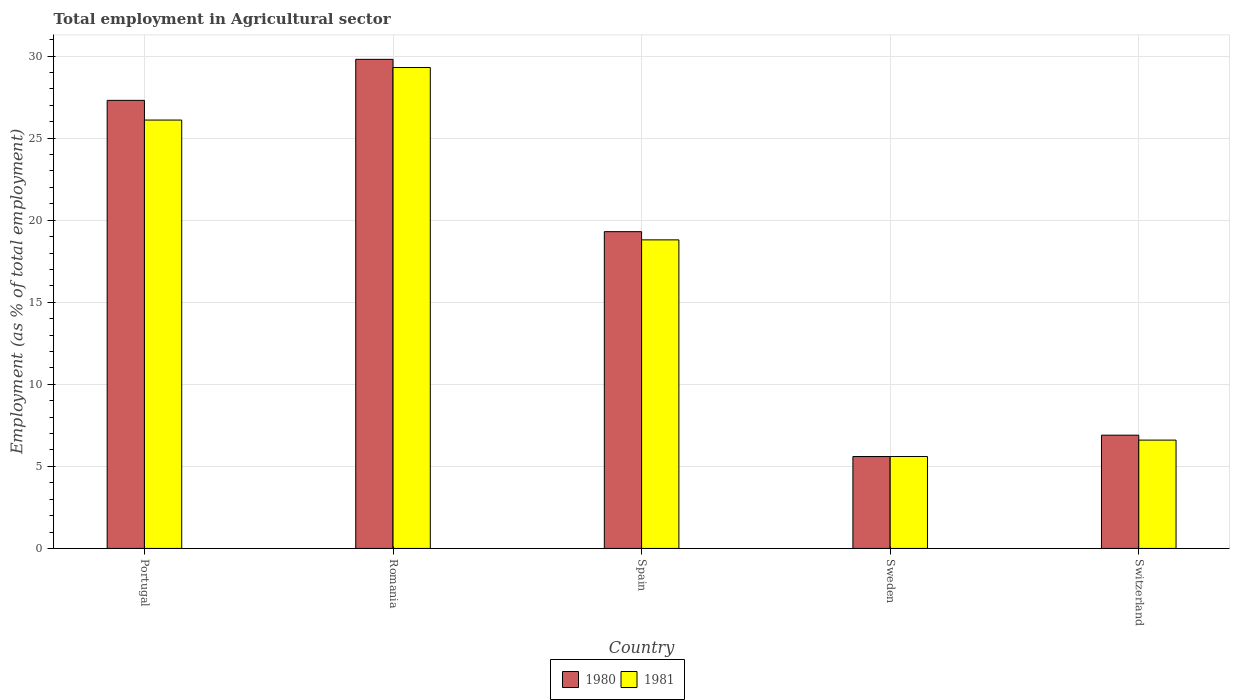How many bars are there on the 2nd tick from the right?
Ensure brevity in your answer.  2. What is the label of the 5th group of bars from the left?
Keep it short and to the point. Switzerland. What is the employment in agricultural sector in 1980 in Spain?
Your answer should be compact. 19.3. Across all countries, what is the maximum employment in agricultural sector in 1981?
Your answer should be very brief. 29.3. Across all countries, what is the minimum employment in agricultural sector in 1980?
Give a very brief answer. 5.6. In which country was the employment in agricultural sector in 1980 maximum?
Provide a succinct answer. Romania. What is the total employment in agricultural sector in 1980 in the graph?
Your answer should be compact. 88.9. What is the difference between the employment in agricultural sector in 1980 in Sweden and that in Switzerland?
Your answer should be compact. -1.3. What is the difference between the employment in agricultural sector in 1980 in Sweden and the employment in agricultural sector in 1981 in Portugal?
Your answer should be compact. -20.5. What is the average employment in agricultural sector in 1980 per country?
Offer a very short reply. 17.78. What is the ratio of the employment in agricultural sector in 1981 in Portugal to that in Switzerland?
Give a very brief answer. 3.95. Is the employment in agricultural sector in 1981 in Portugal less than that in Spain?
Your answer should be very brief. No. Is the difference between the employment in agricultural sector in 1980 in Spain and Switzerland greater than the difference between the employment in agricultural sector in 1981 in Spain and Switzerland?
Give a very brief answer. Yes. What is the difference between the highest and the second highest employment in agricultural sector in 1980?
Provide a short and direct response. -8. What is the difference between the highest and the lowest employment in agricultural sector in 1980?
Give a very brief answer. 24.2. In how many countries, is the employment in agricultural sector in 1981 greater than the average employment in agricultural sector in 1981 taken over all countries?
Keep it short and to the point. 3. Is the sum of the employment in agricultural sector in 1981 in Spain and Sweden greater than the maximum employment in agricultural sector in 1980 across all countries?
Offer a very short reply. No. How many bars are there?
Keep it short and to the point. 10. What is the difference between two consecutive major ticks on the Y-axis?
Your response must be concise. 5. Are the values on the major ticks of Y-axis written in scientific E-notation?
Your answer should be compact. No. Does the graph contain any zero values?
Keep it short and to the point. No. Does the graph contain grids?
Ensure brevity in your answer.  Yes. How many legend labels are there?
Offer a very short reply. 2. How are the legend labels stacked?
Offer a very short reply. Horizontal. What is the title of the graph?
Give a very brief answer. Total employment in Agricultural sector. Does "1979" appear as one of the legend labels in the graph?
Provide a short and direct response. No. What is the label or title of the X-axis?
Your response must be concise. Country. What is the label or title of the Y-axis?
Your answer should be very brief. Employment (as % of total employment). What is the Employment (as % of total employment) of 1980 in Portugal?
Make the answer very short. 27.3. What is the Employment (as % of total employment) in 1981 in Portugal?
Give a very brief answer. 26.1. What is the Employment (as % of total employment) of 1980 in Romania?
Make the answer very short. 29.8. What is the Employment (as % of total employment) of 1981 in Romania?
Your answer should be compact. 29.3. What is the Employment (as % of total employment) in 1980 in Spain?
Make the answer very short. 19.3. What is the Employment (as % of total employment) of 1981 in Spain?
Your answer should be very brief. 18.8. What is the Employment (as % of total employment) in 1980 in Sweden?
Your response must be concise. 5.6. What is the Employment (as % of total employment) in 1981 in Sweden?
Your answer should be very brief. 5.6. What is the Employment (as % of total employment) in 1980 in Switzerland?
Ensure brevity in your answer.  6.9. What is the Employment (as % of total employment) in 1981 in Switzerland?
Give a very brief answer. 6.6. Across all countries, what is the maximum Employment (as % of total employment) of 1980?
Offer a terse response. 29.8. Across all countries, what is the maximum Employment (as % of total employment) in 1981?
Give a very brief answer. 29.3. Across all countries, what is the minimum Employment (as % of total employment) in 1980?
Your response must be concise. 5.6. Across all countries, what is the minimum Employment (as % of total employment) of 1981?
Keep it short and to the point. 5.6. What is the total Employment (as % of total employment) in 1980 in the graph?
Make the answer very short. 88.9. What is the total Employment (as % of total employment) in 1981 in the graph?
Ensure brevity in your answer.  86.4. What is the difference between the Employment (as % of total employment) in 1980 in Portugal and that in Romania?
Provide a short and direct response. -2.5. What is the difference between the Employment (as % of total employment) in 1980 in Portugal and that in Spain?
Provide a short and direct response. 8. What is the difference between the Employment (as % of total employment) of 1981 in Portugal and that in Spain?
Offer a terse response. 7.3. What is the difference between the Employment (as % of total employment) of 1980 in Portugal and that in Sweden?
Offer a very short reply. 21.7. What is the difference between the Employment (as % of total employment) of 1981 in Portugal and that in Sweden?
Offer a very short reply. 20.5. What is the difference between the Employment (as % of total employment) in 1980 in Portugal and that in Switzerland?
Your answer should be very brief. 20.4. What is the difference between the Employment (as % of total employment) of 1980 in Romania and that in Sweden?
Offer a very short reply. 24.2. What is the difference between the Employment (as % of total employment) in 1981 in Romania and that in Sweden?
Offer a very short reply. 23.7. What is the difference between the Employment (as % of total employment) in 1980 in Romania and that in Switzerland?
Offer a very short reply. 22.9. What is the difference between the Employment (as % of total employment) in 1981 in Romania and that in Switzerland?
Your response must be concise. 22.7. What is the difference between the Employment (as % of total employment) of 1980 in Spain and that in Sweden?
Give a very brief answer. 13.7. What is the difference between the Employment (as % of total employment) of 1980 in Spain and that in Switzerland?
Keep it short and to the point. 12.4. What is the difference between the Employment (as % of total employment) in 1981 in Sweden and that in Switzerland?
Your answer should be very brief. -1. What is the difference between the Employment (as % of total employment) in 1980 in Portugal and the Employment (as % of total employment) in 1981 in Spain?
Ensure brevity in your answer.  8.5. What is the difference between the Employment (as % of total employment) in 1980 in Portugal and the Employment (as % of total employment) in 1981 in Sweden?
Your response must be concise. 21.7. What is the difference between the Employment (as % of total employment) in 1980 in Portugal and the Employment (as % of total employment) in 1981 in Switzerland?
Keep it short and to the point. 20.7. What is the difference between the Employment (as % of total employment) of 1980 in Romania and the Employment (as % of total employment) of 1981 in Spain?
Give a very brief answer. 11. What is the difference between the Employment (as % of total employment) in 1980 in Romania and the Employment (as % of total employment) in 1981 in Sweden?
Offer a terse response. 24.2. What is the difference between the Employment (as % of total employment) of 1980 in Romania and the Employment (as % of total employment) of 1981 in Switzerland?
Offer a terse response. 23.2. What is the difference between the Employment (as % of total employment) in 1980 in Spain and the Employment (as % of total employment) in 1981 in Sweden?
Keep it short and to the point. 13.7. What is the difference between the Employment (as % of total employment) in 1980 in Spain and the Employment (as % of total employment) in 1981 in Switzerland?
Offer a very short reply. 12.7. What is the difference between the Employment (as % of total employment) in 1980 in Sweden and the Employment (as % of total employment) in 1981 in Switzerland?
Your answer should be compact. -1. What is the average Employment (as % of total employment) in 1980 per country?
Offer a very short reply. 17.78. What is the average Employment (as % of total employment) of 1981 per country?
Keep it short and to the point. 17.28. What is the difference between the Employment (as % of total employment) in 1980 and Employment (as % of total employment) in 1981 in Romania?
Offer a very short reply. 0.5. What is the difference between the Employment (as % of total employment) in 1980 and Employment (as % of total employment) in 1981 in Sweden?
Offer a terse response. 0. What is the difference between the Employment (as % of total employment) in 1980 and Employment (as % of total employment) in 1981 in Switzerland?
Give a very brief answer. 0.3. What is the ratio of the Employment (as % of total employment) in 1980 in Portugal to that in Romania?
Give a very brief answer. 0.92. What is the ratio of the Employment (as % of total employment) of 1981 in Portugal to that in Romania?
Keep it short and to the point. 0.89. What is the ratio of the Employment (as % of total employment) in 1980 in Portugal to that in Spain?
Make the answer very short. 1.41. What is the ratio of the Employment (as % of total employment) of 1981 in Portugal to that in Spain?
Provide a short and direct response. 1.39. What is the ratio of the Employment (as % of total employment) of 1980 in Portugal to that in Sweden?
Provide a short and direct response. 4.88. What is the ratio of the Employment (as % of total employment) in 1981 in Portugal to that in Sweden?
Offer a terse response. 4.66. What is the ratio of the Employment (as % of total employment) of 1980 in Portugal to that in Switzerland?
Your answer should be compact. 3.96. What is the ratio of the Employment (as % of total employment) of 1981 in Portugal to that in Switzerland?
Provide a succinct answer. 3.95. What is the ratio of the Employment (as % of total employment) of 1980 in Romania to that in Spain?
Your response must be concise. 1.54. What is the ratio of the Employment (as % of total employment) of 1981 in Romania to that in Spain?
Your answer should be compact. 1.56. What is the ratio of the Employment (as % of total employment) of 1980 in Romania to that in Sweden?
Offer a terse response. 5.32. What is the ratio of the Employment (as % of total employment) of 1981 in Romania to that in Sweden?
Give a very brief answer. 5.23. What is the ratio of the Employment (as % of total employment) in 1980 in Romania to that in Switzerland?
Offer a very short reply. 4.32. What is the ratio of the Employment (as % of total employment) in 1981 in Romania to that in Switzerland?
Offer a very short reply. 4.44. What is the ratio of the Employment (as % of total employment) in 1980 in Spain to that in Sweden?
Offer a very short reply. 3.45. What is the ratio of the Employment (as % of total employment) in 1981 in Spain to that in Sweden?
Give a very brief answer. 3.36. What is the ratio of the Employment (as % of total employment) of 1980 in Spain to that in Switzerland?
Provide a succinct answer. 2.8. What is the ratio of the Employment (as % of total employment) of 1981 in Spain to that in Switzerland?
Keep it short and to the point. 2.85. What is the ratio of the Employment (as % of total employment) of 1980 in Sweden to that in Switzerland?
Your response must be concise. 0.81. What is the ratio of the Employment (as % of total employment) of 1981 in Sweden to that in Switzerland?
Give a very brief answer. 0.85. What is the difference between the highest and the second highest Employment (as % of total employment) in 1980?
Offer a terse response. 2.5. What is the difference between the highest and the second highest Employment (as % of total employment) in 1981?
Offer a very short reply. 3.2. What is the difference between the highest and the lowest Employment (as % of total employment) of 1980?
Keep it short and to the point. 24.2. What is the difference between the highest and the lowest Employment (as % of total employment) in 1981?
Keep it short and to the point. 23.7. 